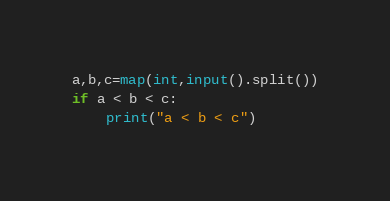Convert code to text. <code><loc_0><loc_0><loc_500><loc_500><_Python_>a,b,c=map(int,input().split())
if a < b < c:
    print("a < b < c")
</code> 